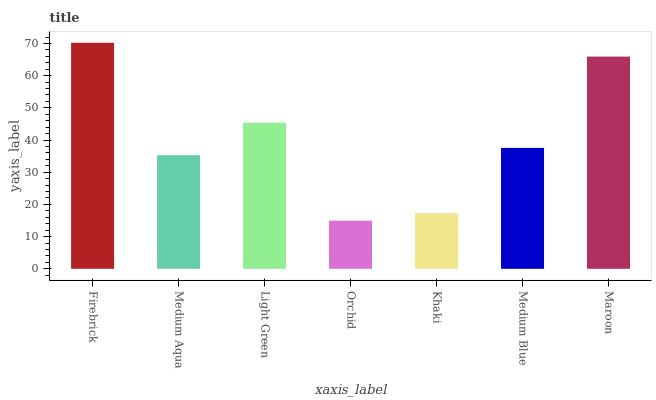Is Orchid the minimum?
Answer yes or no. Yes. Is Firebrick the maximum?
Answer yes or no. Yes. Is Medium Aqua the minimum?
Answer yes or no. No. Is Medium Aqua the maximum?
Answer yes or no. No. Is Firebrick greater than Medium Aqua?
Answer yes or no. Yes. Is Medium Aqua less than Firebrick?
Answer yes or no. Yes. Is Medium Aqua greater than Firebrick?
Answer yes or no. No. Is Firebrick less than Medium Aqua?
Answer yes or no. No. Is Medium Blue the high median?
Answer yes or no. Yes. Is Medium Blue the low median?
Answer yes or no. Yes. Is Orchid the high median?
Answer yes or no. No. Is Orchid the low median?
Answer yes or no. No. 